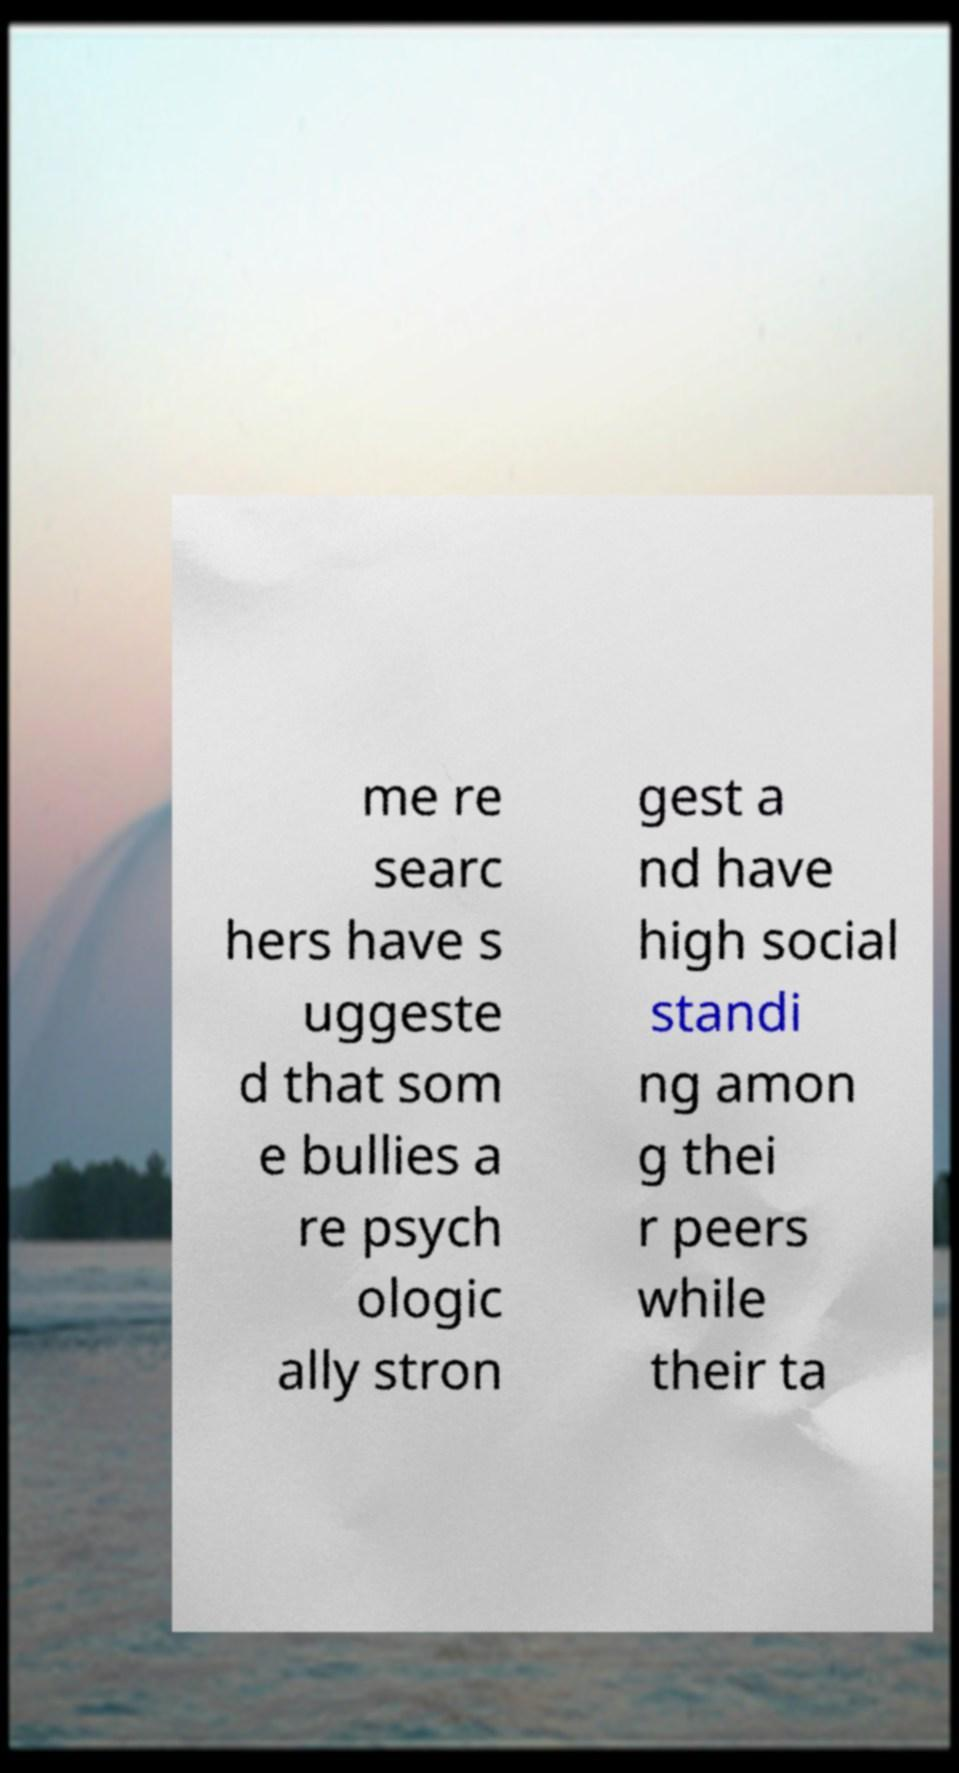I need the written content from this picture converted into text. Can you do that? me re searc hers have s uggeste d that som e bullies a re psych ologic ally stron gest a nd have high social standi ng amon g thei r peers while their ta 